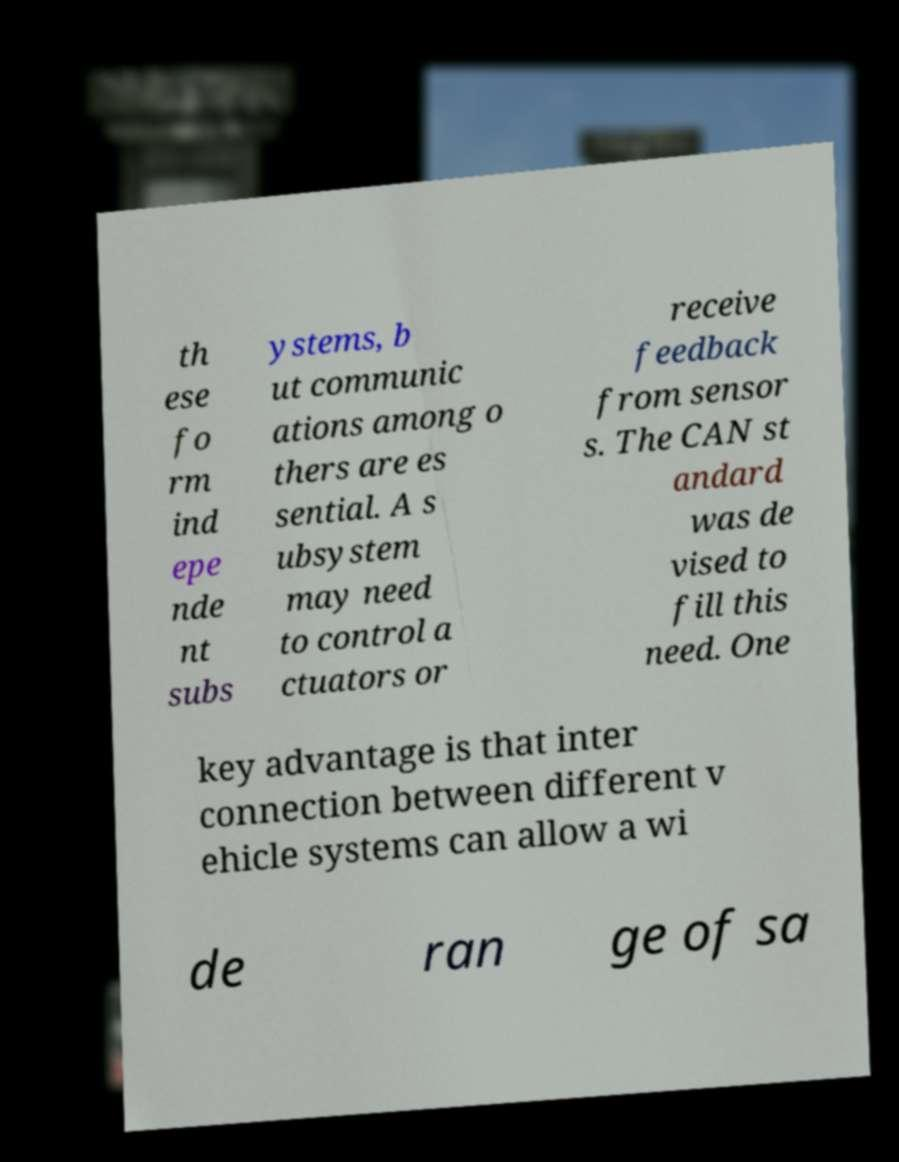I need the written content from this picture converted into text. Can you do that? th ese fo rm ind epe nde nt subs ystems, b ut communic ations among o thers are es sential. A s ubsystem may need to control a ctuators or receive feedback from sensor s. The CAN st andard was de vised to fill this need. One key advantage is that inter connection between different v ehicle systems can allow a wi de ran ge of sa 